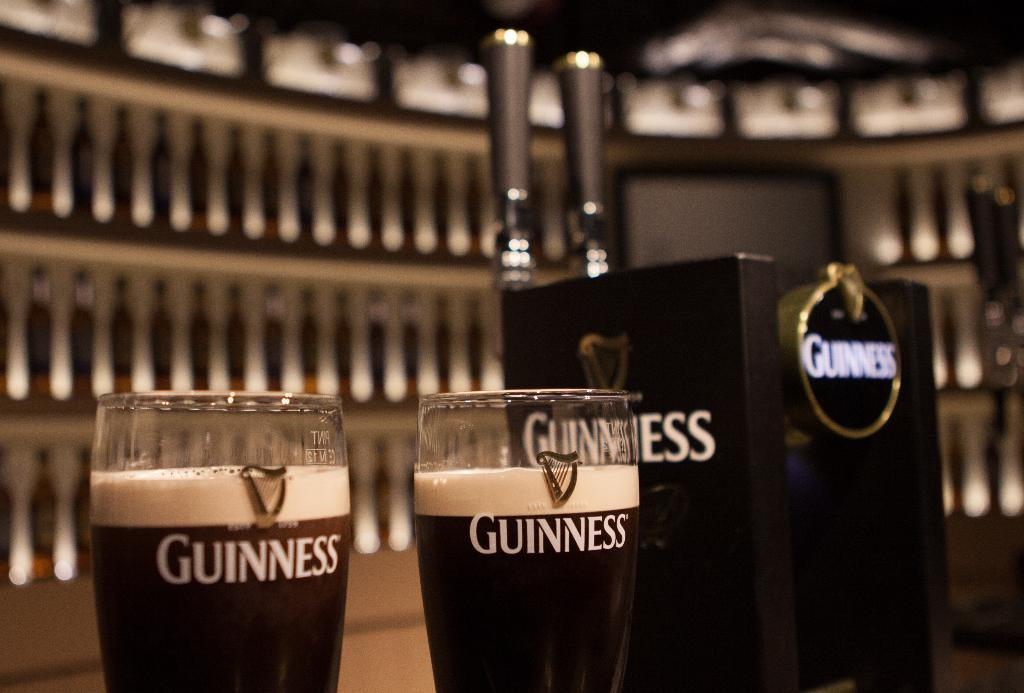<image>
Present a compact description of the photo's key features. Two glasses of Guinness sit next to a set of Guinness taps at a bar. 